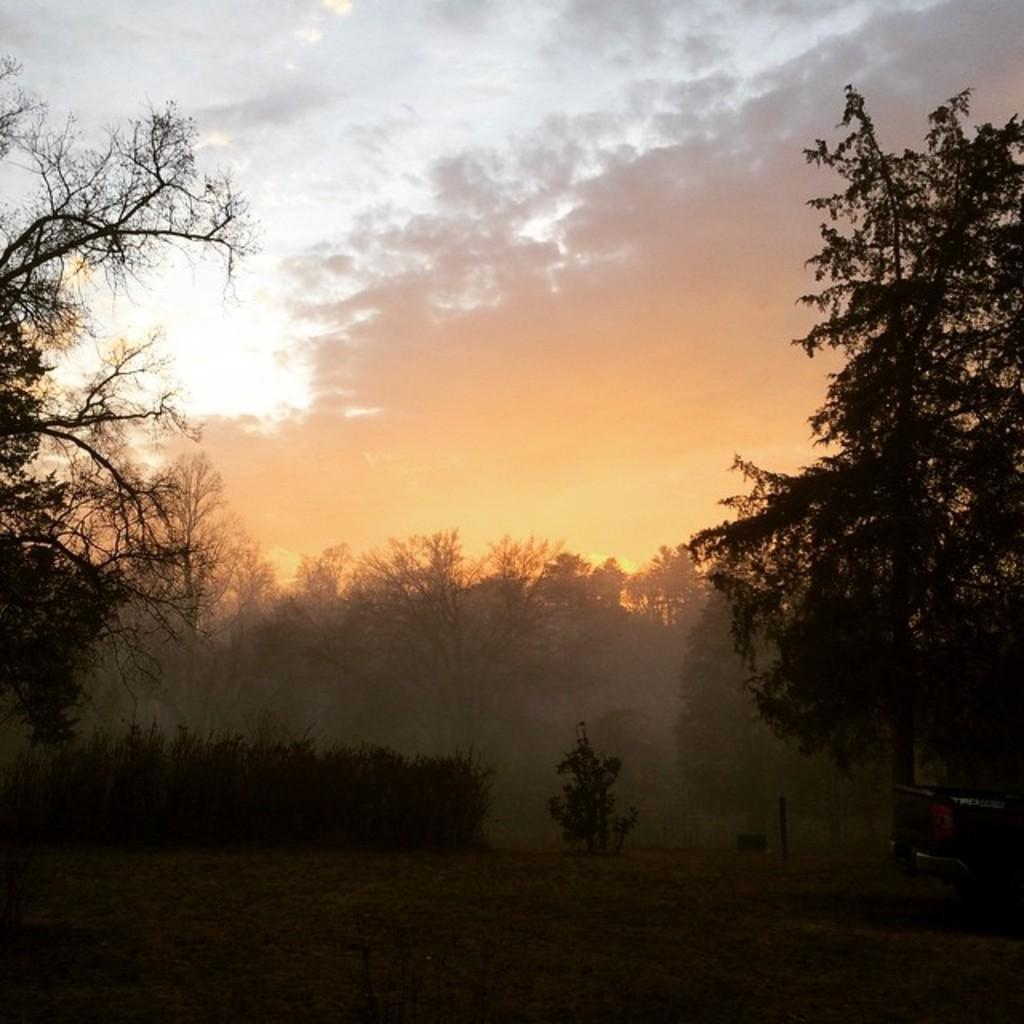What type of vegetation is present in the image? There are many trees in the image. What can be seen in the sky at the top of the image? There are clouds in the sky at the top of the image. What color is the grass on the ground at the bottom of the image? The grass on the ground at the bottom of the image is green. What type of wave can be seen crashing on the shore in the image? There is no shore or wave present in the image; it features trees, clouds, and grass. What place is depicted in the image? The image does not depict a specific place; it shows a natural landscape with trees, clouds, and grass. 